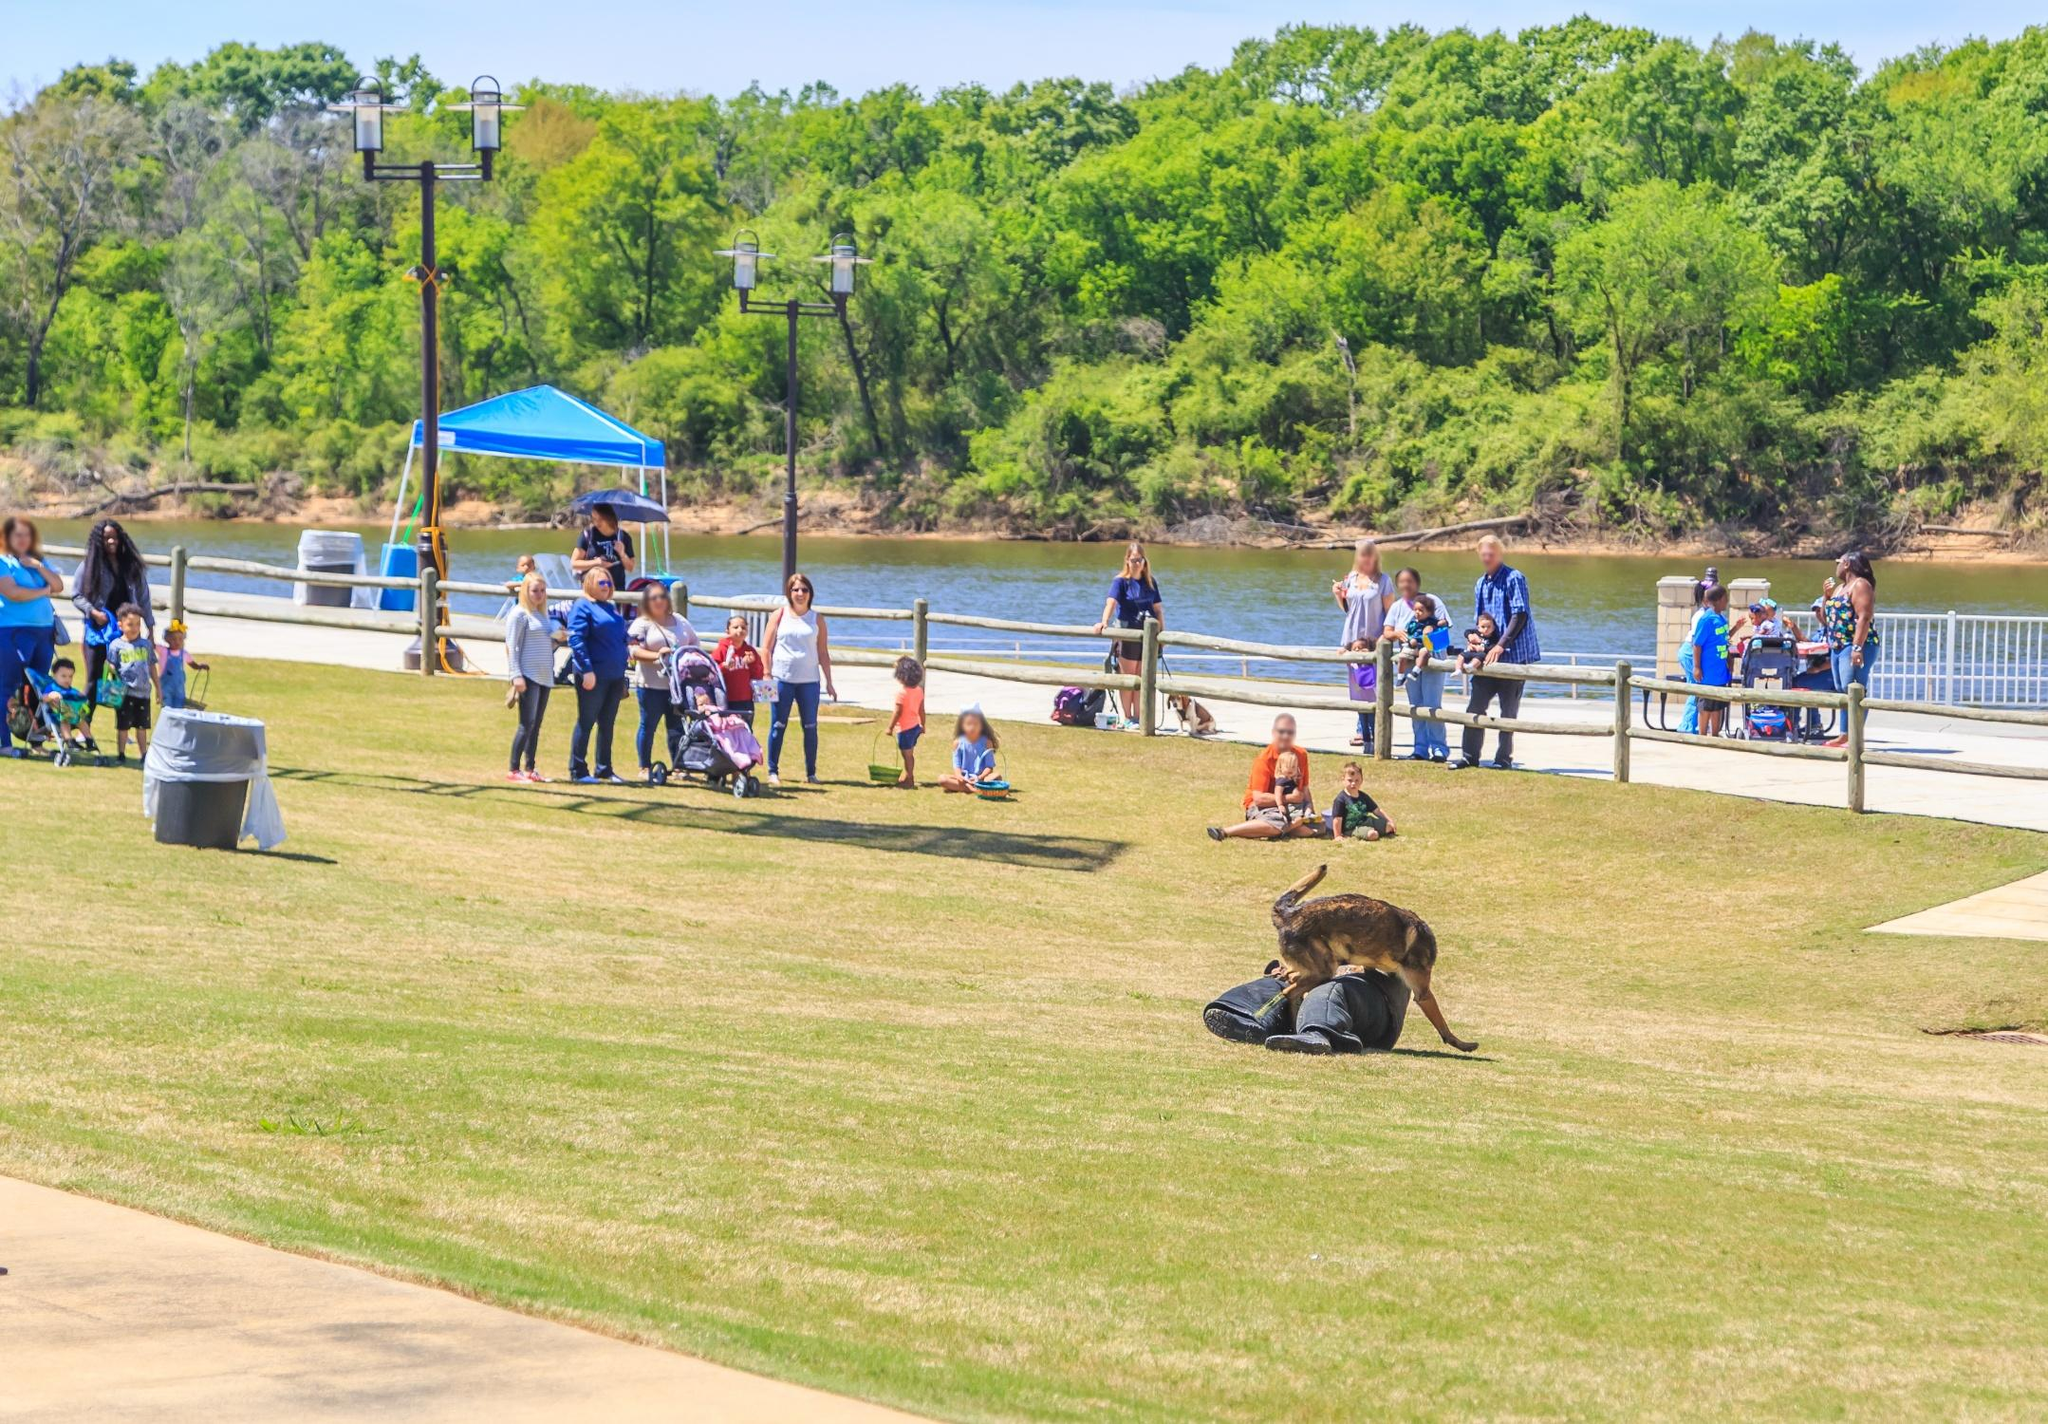Imagine if the setting was taking place in a fantasy world. In a fantastical version of this park, the serene river would be a shimmering stream of liquid silver, reflecting the enchanted forest that borders it. The trees would be massive with luminescent leaves, casting a magical glow over the park. The walkway would be paved with sparkling stones, and mystical creatures, such as fairies and talking animals, would roam freely among the visitors. The blue canopy would be a celestial tent that changes colors, offering enchanted performances by mythical beings. Each corner of the park would hold secrets waiting to be discovered, from hidden portals to other realms to magical fountains granting wishes. 